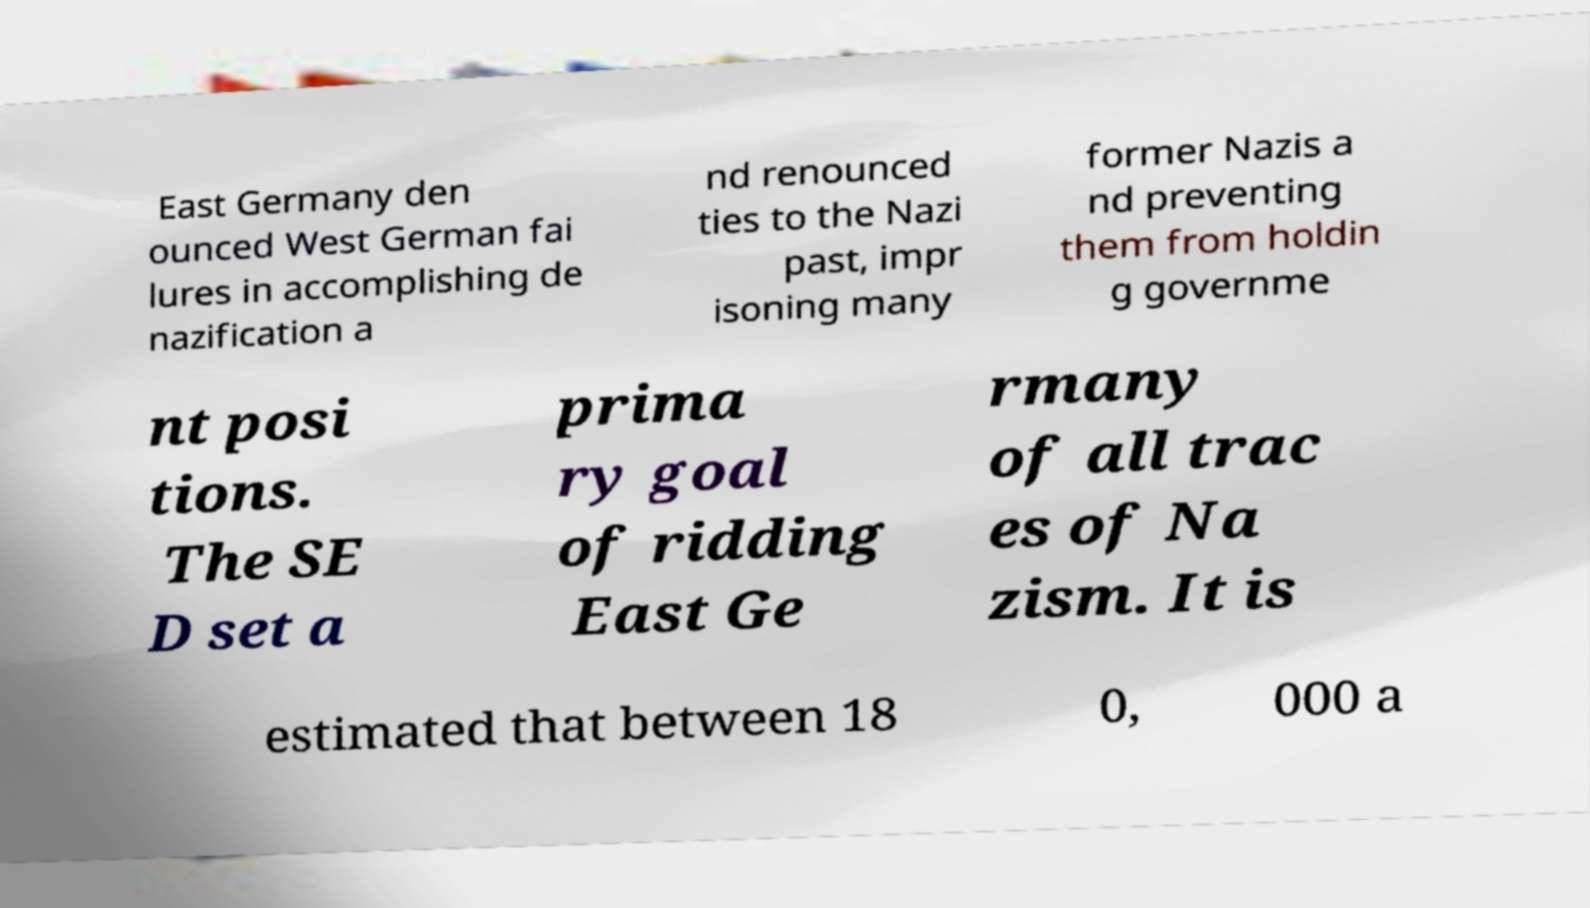What messages or text are displayed in this image? I need them in a readable, typed format. East Germany den ounced West German fai lures in accomplishing de nazification a nd renounced ties to the Nazi past, impr isoning many former Nazis a nd preventing them from holdin g governme nt posi tions. The SE D set a prima ry goal of ridding East Ge rmany of all trac es of Na zism. It is estimated that between 18 0, 000 a 